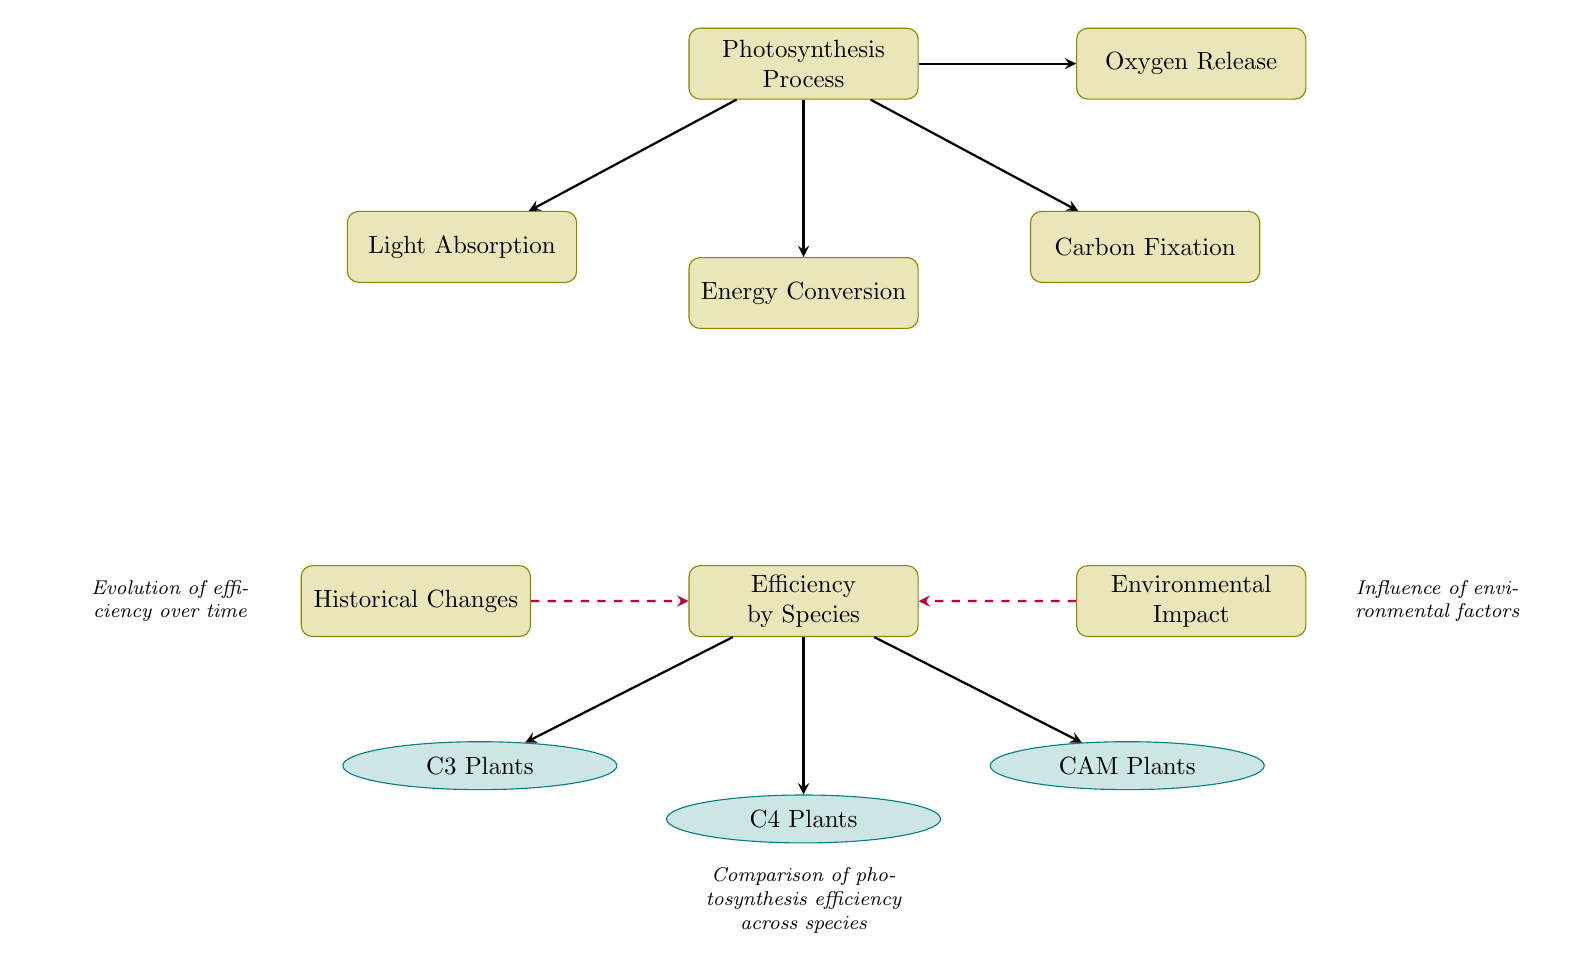What is the primary process depicted in the diagram? The diagram centers around the "Photosynthesis Process," which is the starting point and main theme of the visual representation.
Answer: Photosynthesis Process How many species are represented in the efficiency section? Three species are indicated in the efficiency section: C3 Plants, C4 Plants, and CAM Plants. This is shown by the three connected nodes listed below the "Efficiency by Species" node.
Answer: 3 What is the output of the photosynthesis process according to the diagram? The diagram specifies "Oxygen Release" as one of the outcomes of the photosynthesis process, illustrating a key product generated during the process.
Answer: Oxygen Release Which species is linked directly to the efficiency section? C3 Plants, C4 Plants, and CAM Plants are all directly linked to the "Efficiency by Species" section, demonstrating their comparison regarding photosynthesis efficiency.
Answer: C3 Plants, C4 Plants, CAM Plants What influences the efficiency of photosynthesis according to the diagram? The diagram indicates that both "Historical Changes" and "Environmental Impact" influence photosynthesis efficiency, represented by the dashed arrows pointing to the efficiency node.
Answer: Historical Changes, Environmental Impact How does environmental impact relate to efficiency? The efficiency by species is influenced by environmental impact, as shown by the dashed arrow connecting the "Environmental Impact" node to the "Efficiency by Species" node, indicating a relationship between the two concepts.
Answer: Environmental Impact What type of plants are categorized under C4 in the efficiency section? The "C4 Plants" node is explicitly labeled in the efficiency section as part of the comparative analysis of photosynthesis efficiency among different plant types.
Answer: C4 Plants What is the primary focus of the historical changes in the diagram? Historical changes primarily relate to the "Evolution of efficiency over time," emphasizing the adaptability and changes in photosynthesis efficiency in botanical species through different historical periods.
Answer: Evolution of efficiency over time 